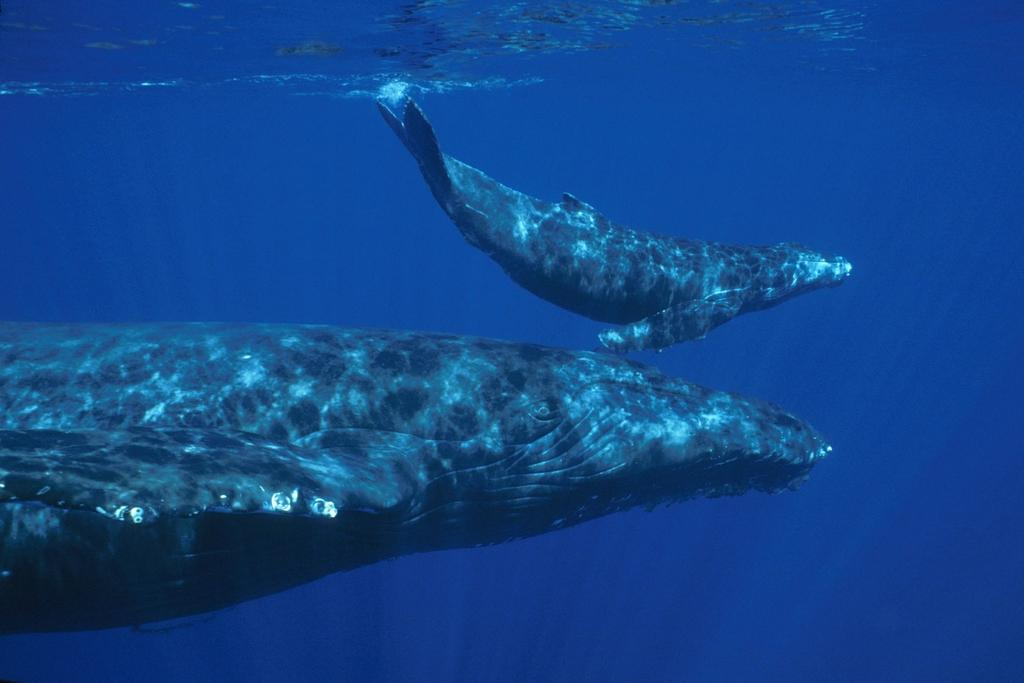What type of objects are the wheels attached to in the image? The information provided does not specify what the wheels are attached to. Where are the wheels located in the image? The wheels are underwater in the image. What is the setting of the image? The setting appears to be an ocean. How many servants can be seen attending to the grandmother in the image? There are no servants or grandmothers present in the image; it features two wheels underwater in an ocean setting. What type of snails are visible in the image? There are no snails visible in the image; it features two wheels underwater in an ocean setting. 